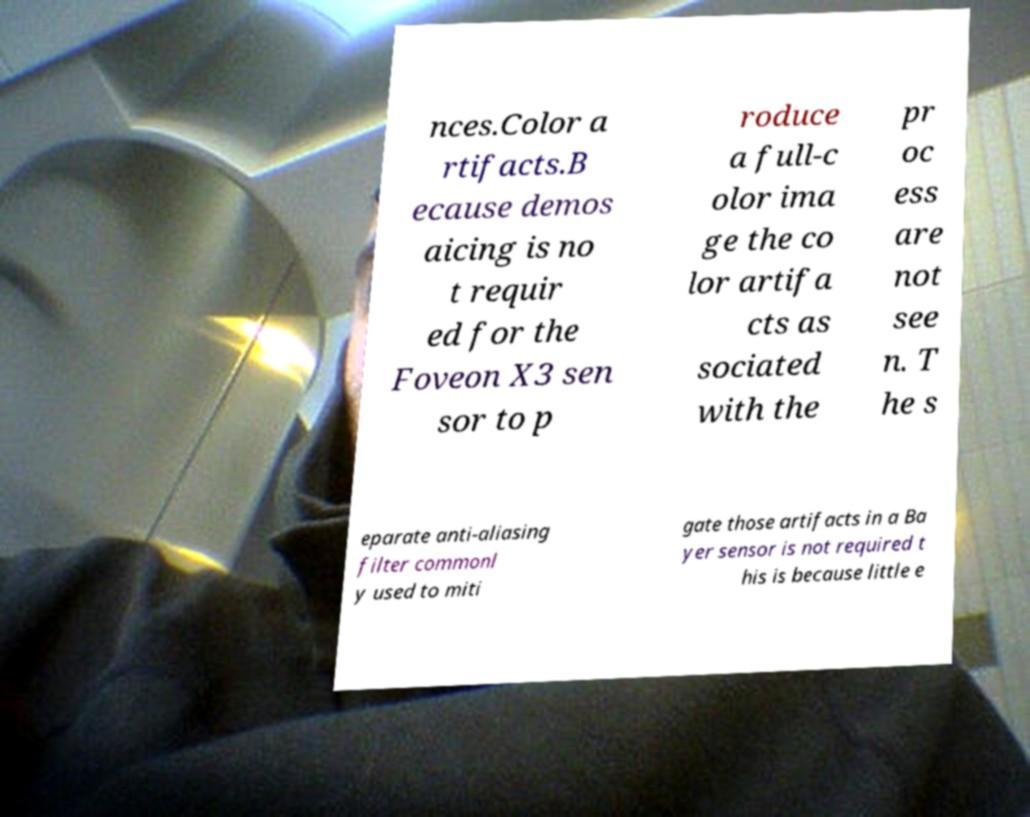Please identify and transcribe the text found in this image. nces.Color a rtifacts.B ecause demos aicing is no t requir ed for the Foveon X3 sen sor to p roduce a full-c olor ima ge the co lor artifa cts as sociated with the pr oc ess are not see n. T he s eparate anti-aliasing filter commonl y used to miti gate those artifacts in a Ba yer sensor is not required t his is because little e 